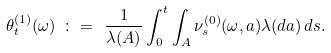<formula> <loc_0><loc_0><loc_500><loc_500>\theta _ { t } ^ { ( 1 ) } ( \omega ) \ \colon = \ \frac { 1 } { \lambda ( A ) } \int _ { 0 } ^ { t } \int _ { A } \nu _ { s } ^ { ( 0 ) } ( \omega , a ) \lambda ( d a ) \, d s .</formula> 